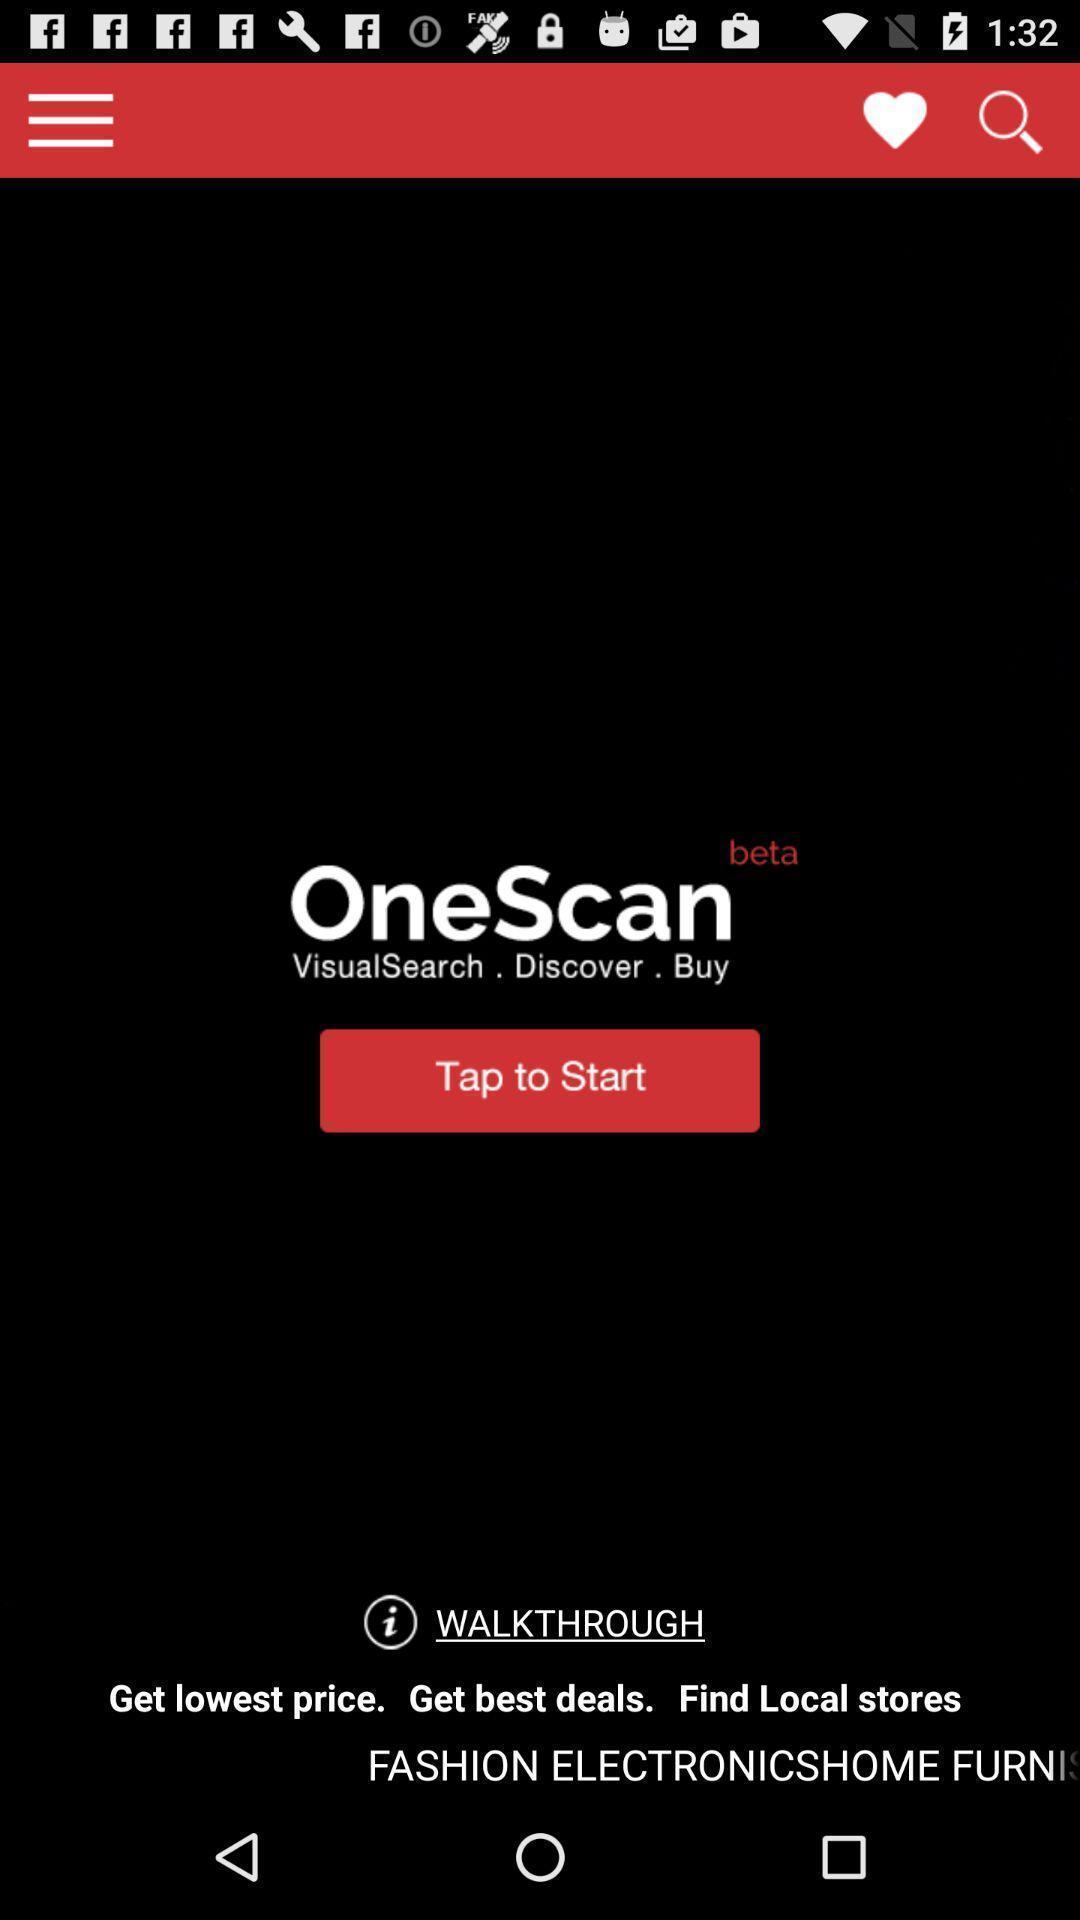Provide a textual representation of this image. Welcome page with available options. 